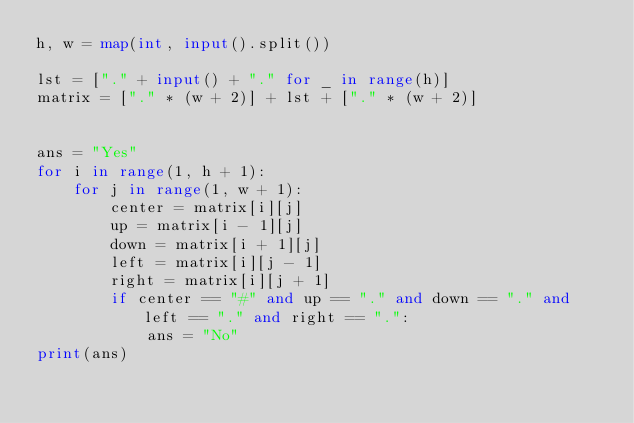Convert code to text. <code><loc_0><loc_0><loc_500><loc_500><_Python_>h, w = map(int, input().split())

lst = ["." + input() + "." for _ in range(h)]
matrix = ["." * (w + 2)] + lst + ["." * (w + 2)]


ans = "Yes"
for i in range(1, h + 1):
    for j in range(1, w + 1):
        center = matrix[i][j]
        up = matrix[i - 1][j]
        down = matrix[i + 1][j]
        left = matrix[i][j - 1]
        right = matrix[i][j + 1]
        if center == "#" and up == "." and down == "." and left == "." and right == ".":
            ans = "No"
print(ans)</code> 